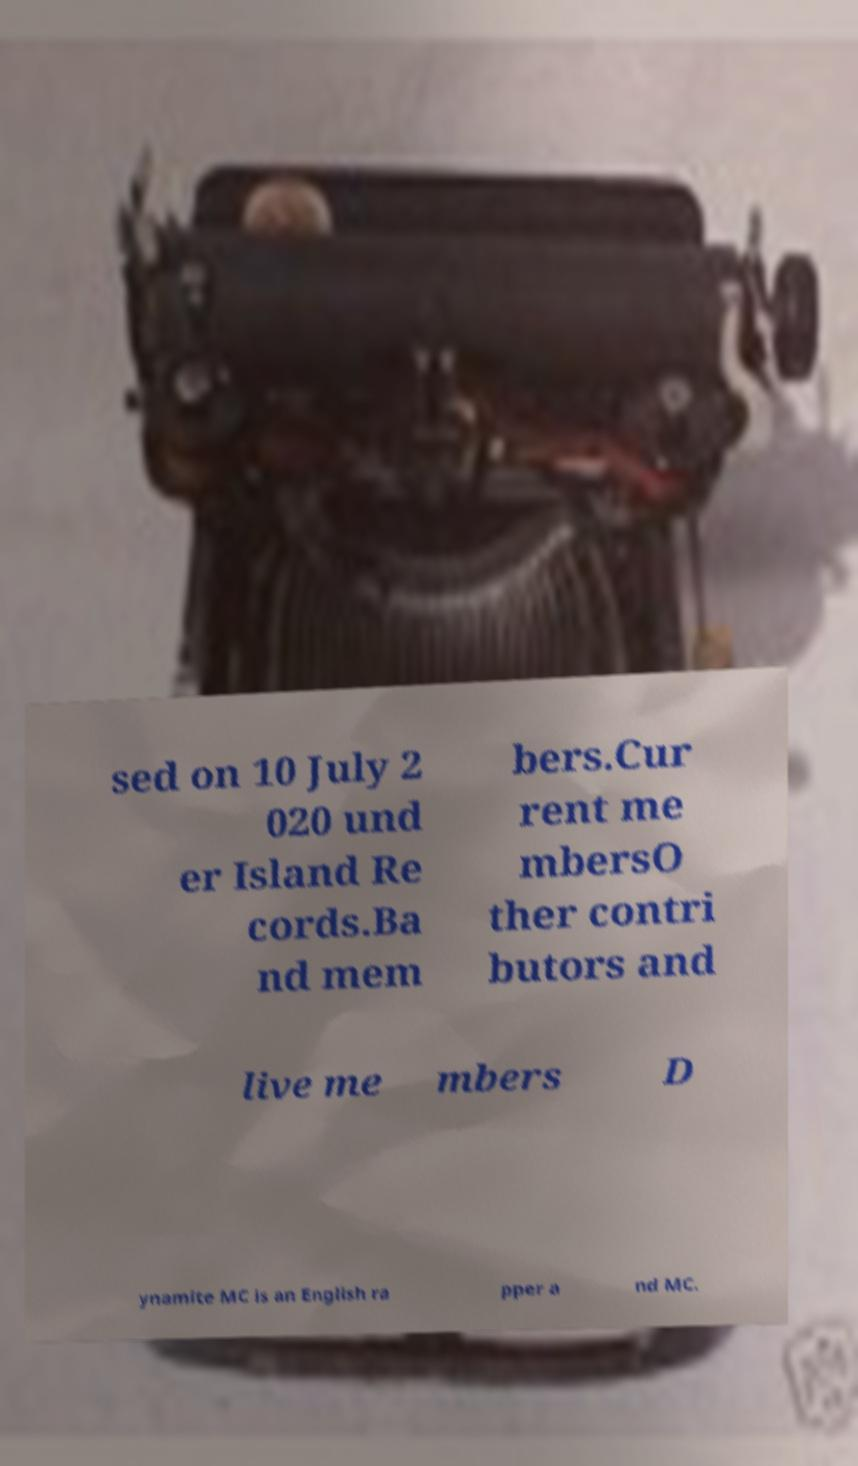Can you accurately transcribe the text from the provided image for me? sed on 10 July 2 020 und er Island Re cords.Ba nd mem bers.Cur rent me mbersO ther contri butors and live me mbers D ynamite MC is an English ra pper a nd MC. 